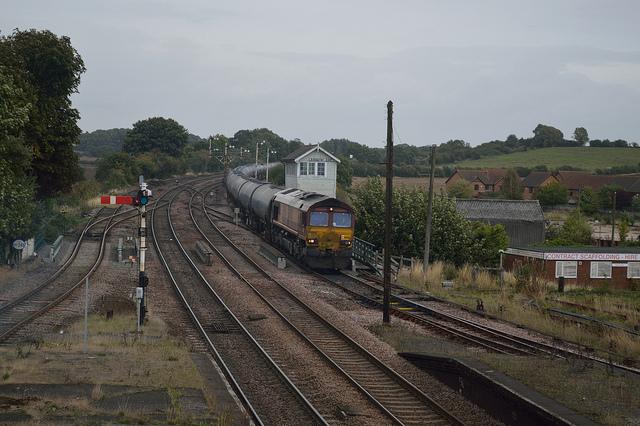Is this photo taken during the day or night?
Give a very brief answer. Day. How many cars on the train?
Concise answer only. Lot. How many windows does the front of the train have?
Answer briefly. 2. How many train cars are there?
Quick response, please. 7. How many train tracks is there?
Keep it brief. 4. How many tracks are visible?
Write a very short answer. 4. Is there a train on the far right track?
Quick response, please. Yes. Are the train cars parked?
Keep it brief. No. How many rail tracks are there?
Be succinct. 4. What is the function of the building on the far right?
Write a very short answer. House. Is there a city in the background?
Keep it brief. No. Do you see any numbers?
Give a very brief answer. No. Does the train have a shadow?
Answer briefly. No. Are the tracks busy?
Short answer required. No. Is this black and white?
Keep it brief. No. What colors are the trains?
Be succinct. Yellow and red. How many train tracks can be seen?
Concise answer only. 4. Is it a sunny day?
Write a very short answer. No. How many train tracks are there?
Quick response, please. 4. What kind of train is that?
Keep it brief. Freight. 